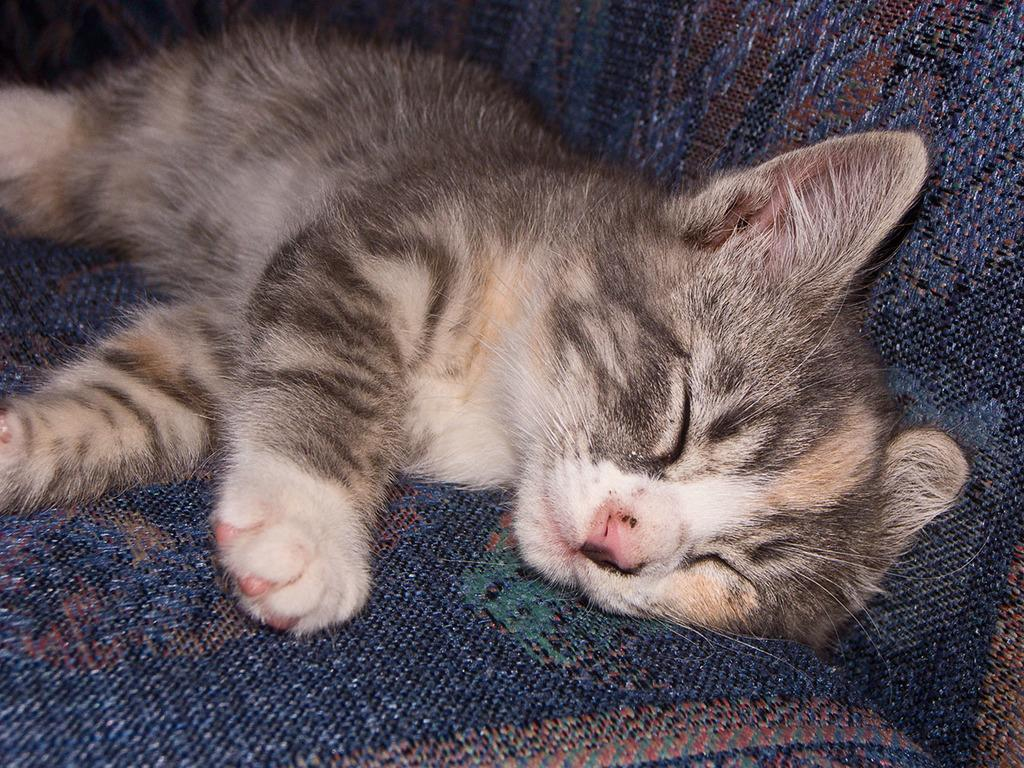What animal can be seen in the image? There is a cat in the image. What is the cat doing in the image? The cat is sleeping. Where is the cat located in the image? The cat is on a sofa. What color is the sofa or bed in the background? There is a blue sofa or bed in the background. What type of coat is the cat wearing in the image? The cat is not wearing a coat in the image. Cats do not typically wear coats. 